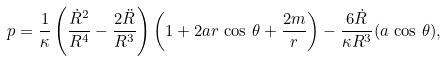<formula> <loc_0><loc_0><loc_500><loc_500>p = \frac { 1 } { \kappa } \left ( \frac { \dot { R } ^ { 2 } } { R ^ { 4 } } - \frac { 2 \ddot { R } } { R ^ { 3 } } \right ) \left ( 1 + 2 a r \, \cos \, \theta + \frac { 2 m } { r } \right ) - \frac { 6 \dot { R } } { \kappa R ^ { 3 } } ( a \, \cos \, \theta ) ,</formula> 